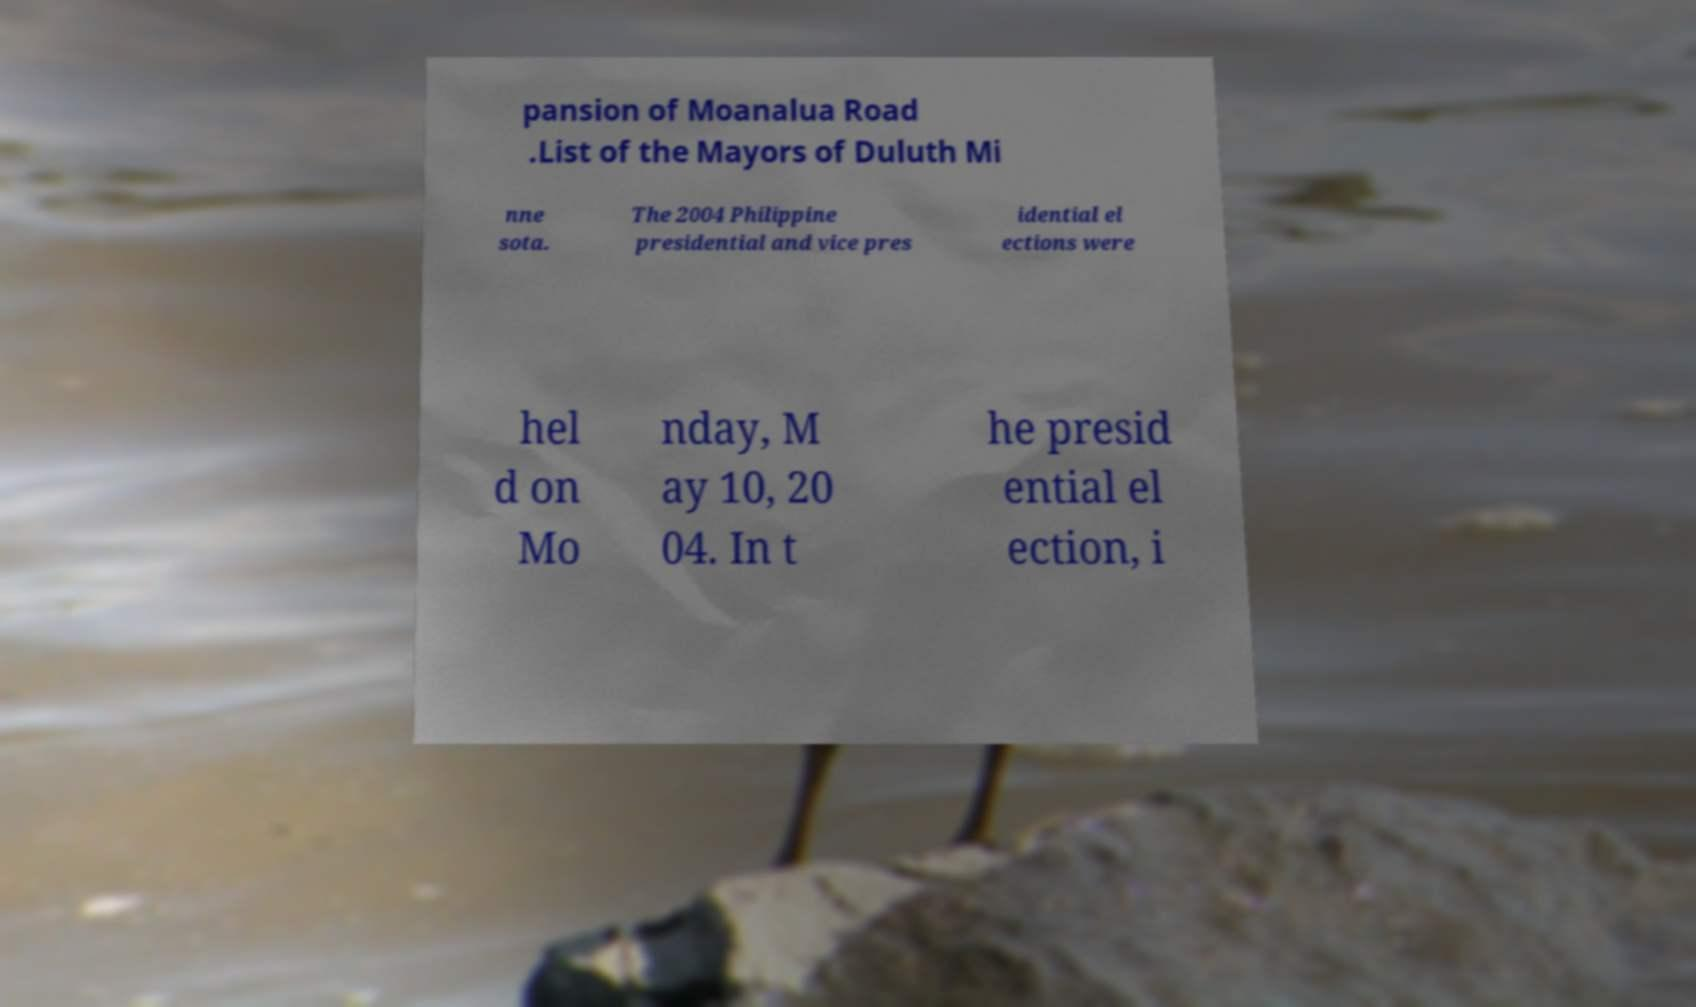For documentation purposes, I need the text within this image transcribed. Could you provide that? pansion of Moanalua Road .List of the Mayors of Duluth Mi nne sota. The 2004 Philippine presidential and vice pres idential el ections were hel d on Mo nday, M ay 10, 20 04. In t he presid ential el ection, i 